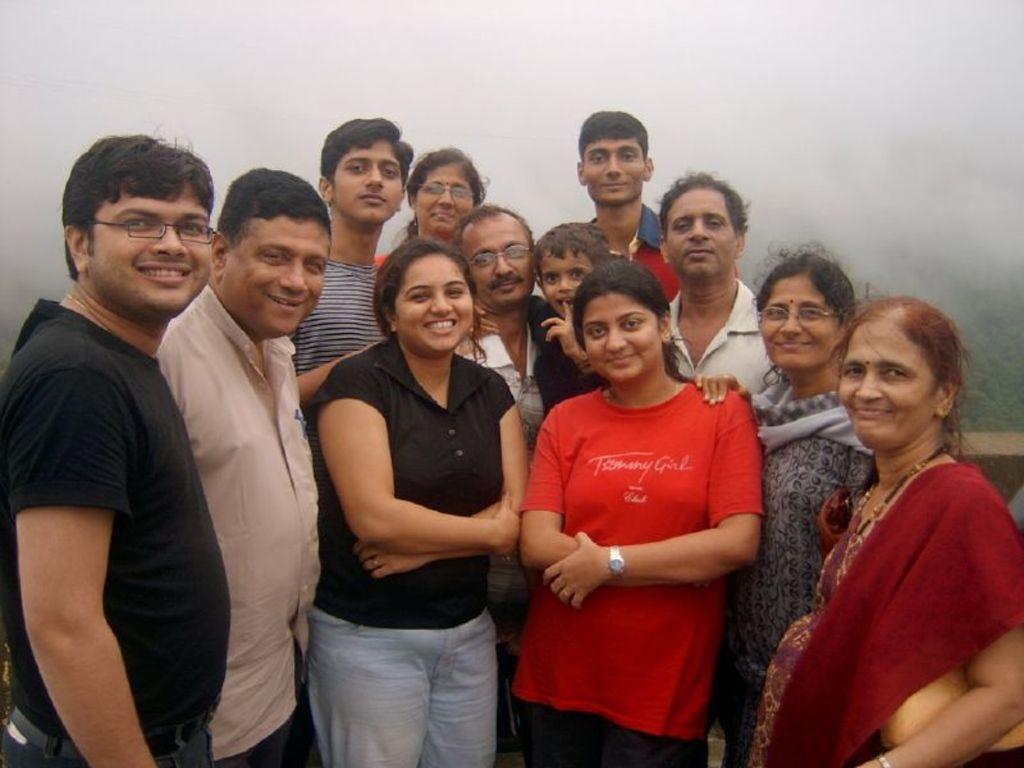How would you summarize this image in a sentence or two? In this image, there are a few people. In the background, we can see the fog. We can see some plants and an object on the right. 